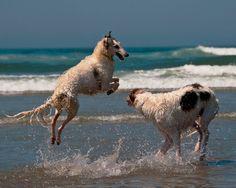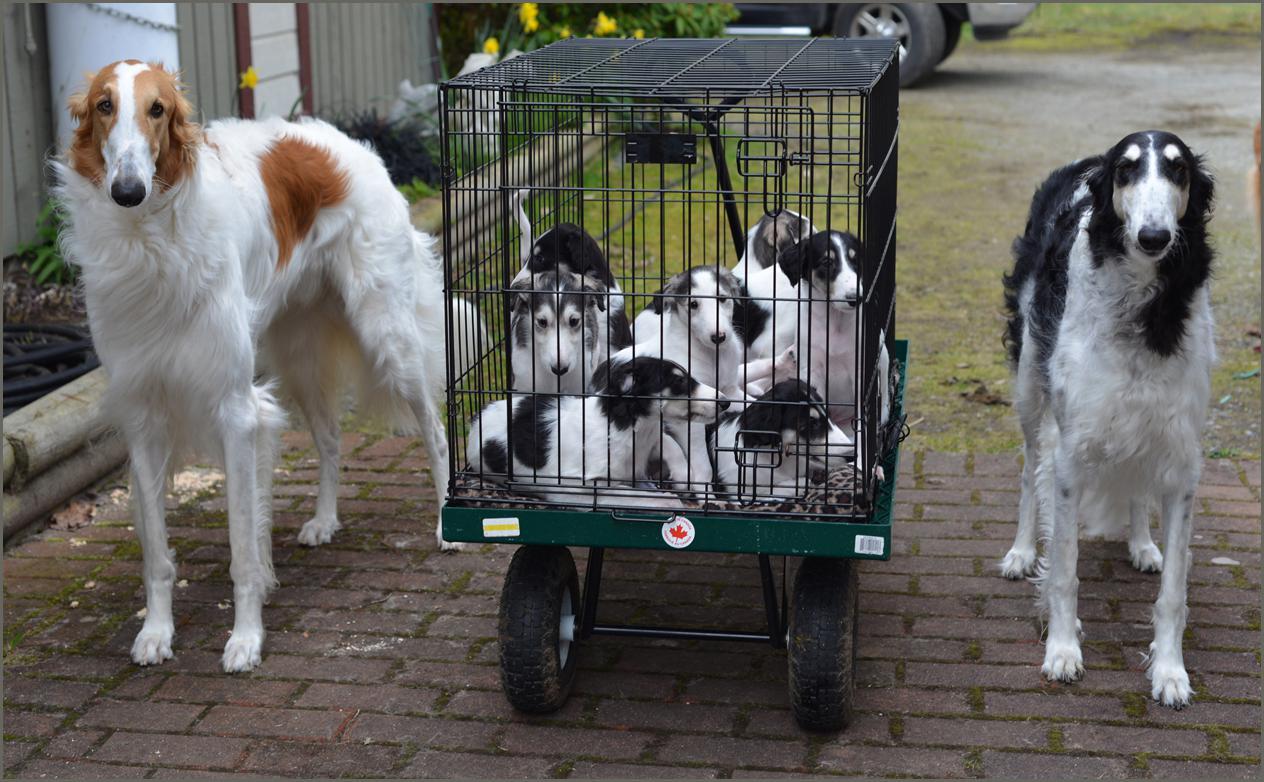The first image is the image on the left, the second image is the image on the right. For the images displayed, is the sentence "A single dog is in the water in the image on the right." factually correct? Answer yes or no. No. The first image is the image on the left, the second image is the image on the right. For the images displayed, is the sentence "In the image on the left a dog is leaping into the air by the water." factually correct? Answer yes or no. Yes. 